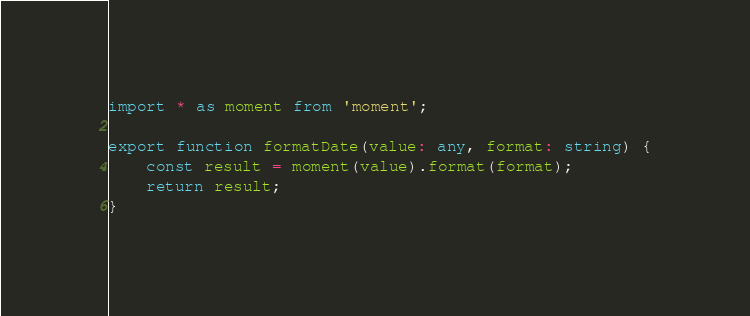<code> <loc_0><loc_0><loc_500><loc_500><_TypeScript_>import * as moment from 'moment';

export function formatDate(value: any, format: string) {
    const result = moment(value).format(format);
    return result;
}
</code> 